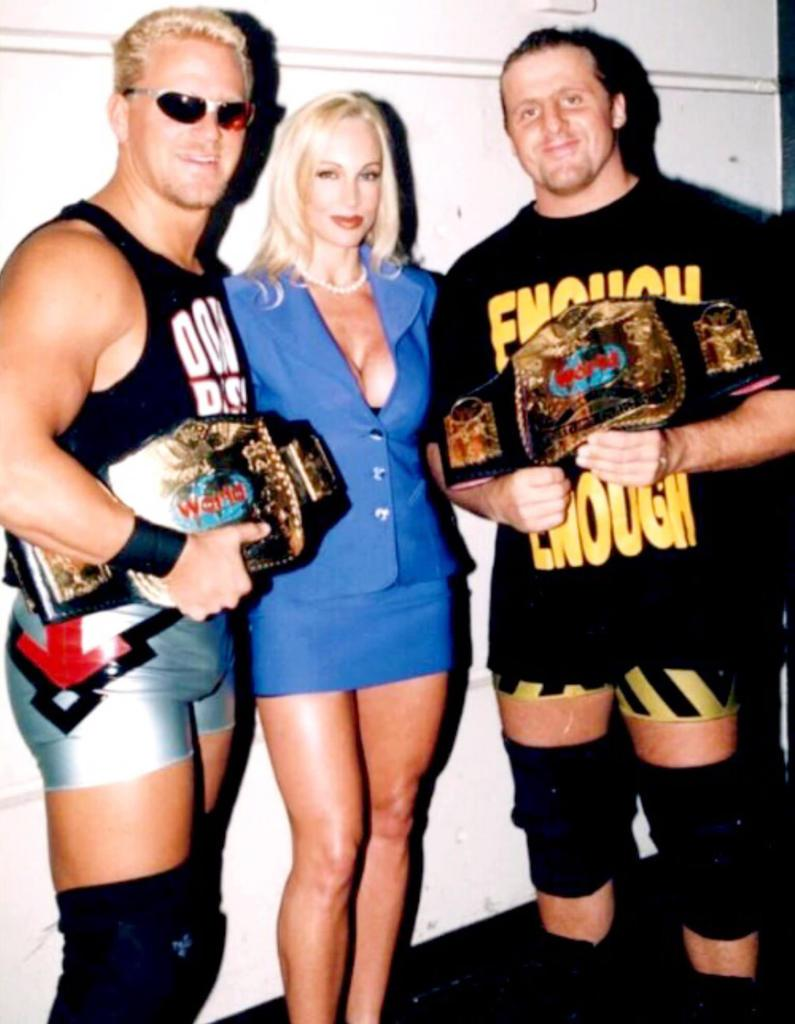Provide a one-sentence caption for the provided image. A woman is standing in between two wrestlers that are holding belts that say World on them. 